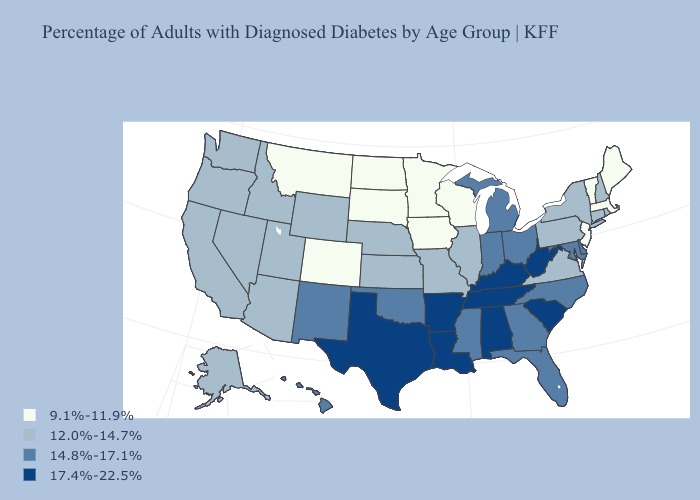Does Colorado have the same value as Minnesota?
Answer briefly. Yes. Which states hav the highest value in the Northeast?
Short answer required. Connecticut, New Hampshire, New York, Pennsylvania, Rhode Island. Does Oregon have the lowest value in the USA?
Give a very brief answer. No. Among the states that border Rhode Island , which have the lowest value?
Be succinct. Massachusetts. What is the value of Missouri?
Give a very brief answer. 12.0%-14.7%. Does Pennsylvania have the lowest value in the Northeast?
Give a very brief answer. No. What is the value of Rhode Island?
Keep it brief. 12.0%-14.7%. Which states hav the highest value in the West?
Concise answer only. Hawaii, New Mexico. Among the states that border Montana , does Wyoming have the highest value?
Concise answer only. Yes. What is the value of Nevada?
Concise answer only. 12.0%-14.7%. Which states have the lowest value in the Northeast?
Keep it brief. Maine, Massachusetts, New Jersey, Vermont. Among the states that border Kansas , which have the highest value?
Short answer required. Oklahoma. Which states have the lowest value in the USA?
Give a very brief answer. Colorado, Iowa, Maine, Massachusetts, Minnesota, Montana, New Jersey, North Dakota, South Dakota, Vermont, Wisconsin. What is the value of Colorado?
Write a very short answer. 9.1%-11.9%. What is the value of Utah?
Give a very brief answer. 12.0%-14.7%. 